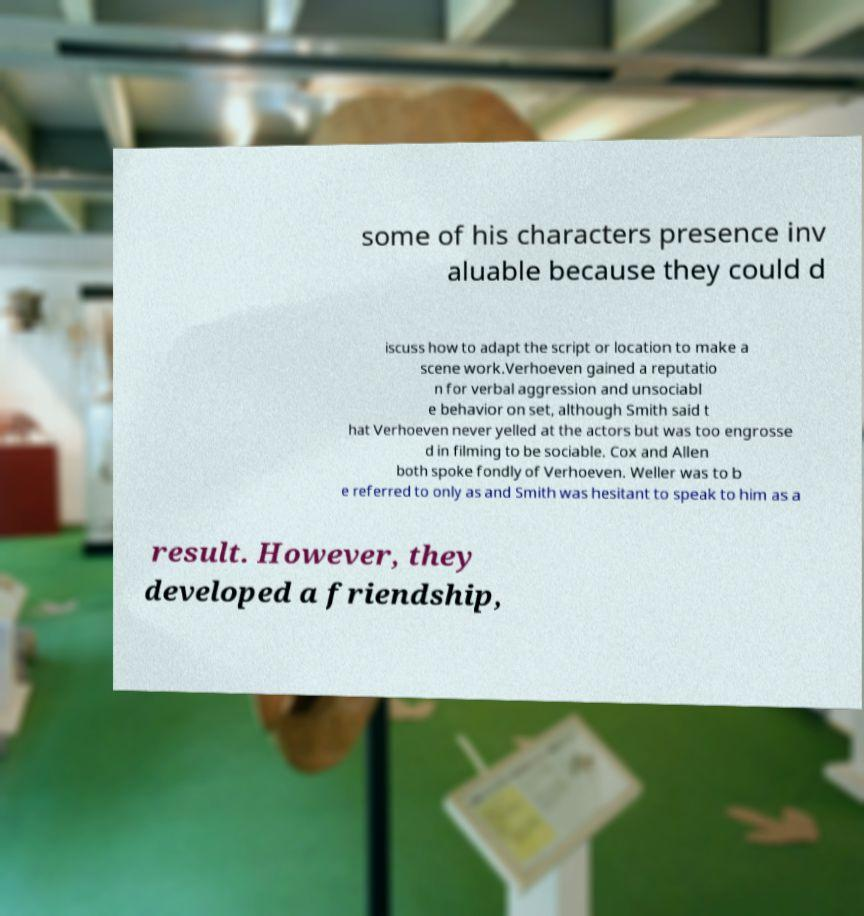Can you read and provide the text displayed in the image?This photo seems to have some interesting text. Can you extract and type it out for me? some of his characters presence inv aluable because they could d iscuss how to adapt the script or location to make a scene work.Verhoeven gained a reputatio n for verbal aggression and unsociabl e behavior on set, although Smith said t hat Verhoeven never yelled at the actors but was too engrosse d in filming to be sociable. Cox and Allen both spoke fondly of Verhoeven. Weller was to b e referred to only as and Smith was hesitant to speak to him as a result. However, they developed a friendship, 